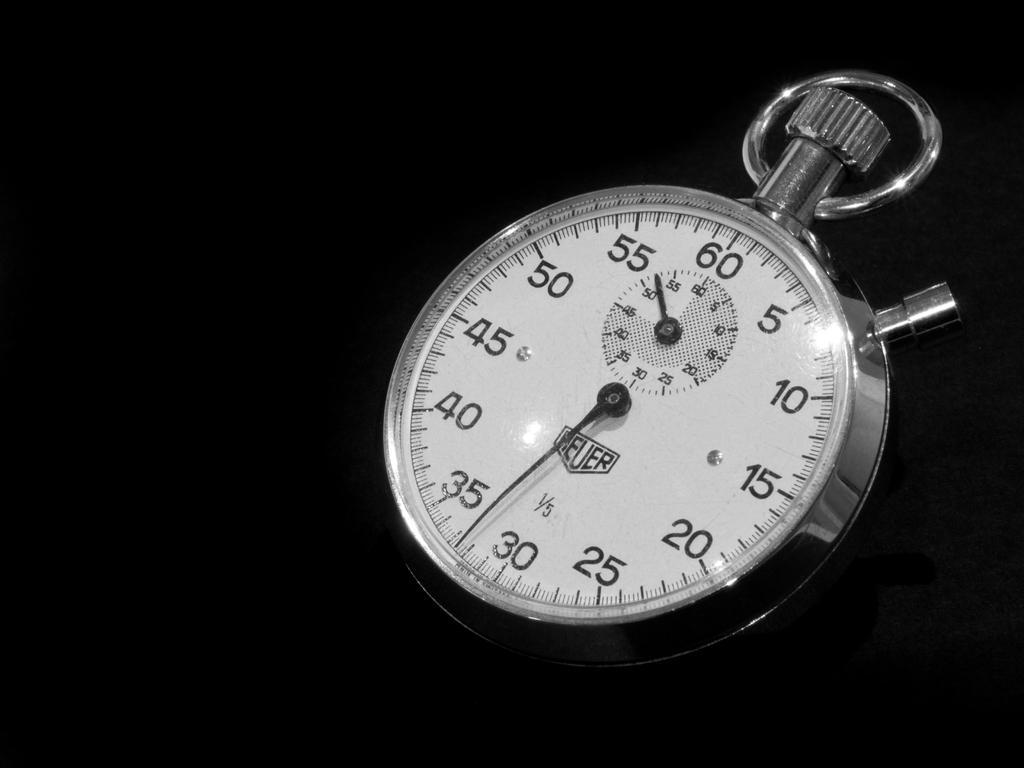In one or two sentences, can you explain what this image depicts? In this image we can see a dial and the background of the image is in black color. 